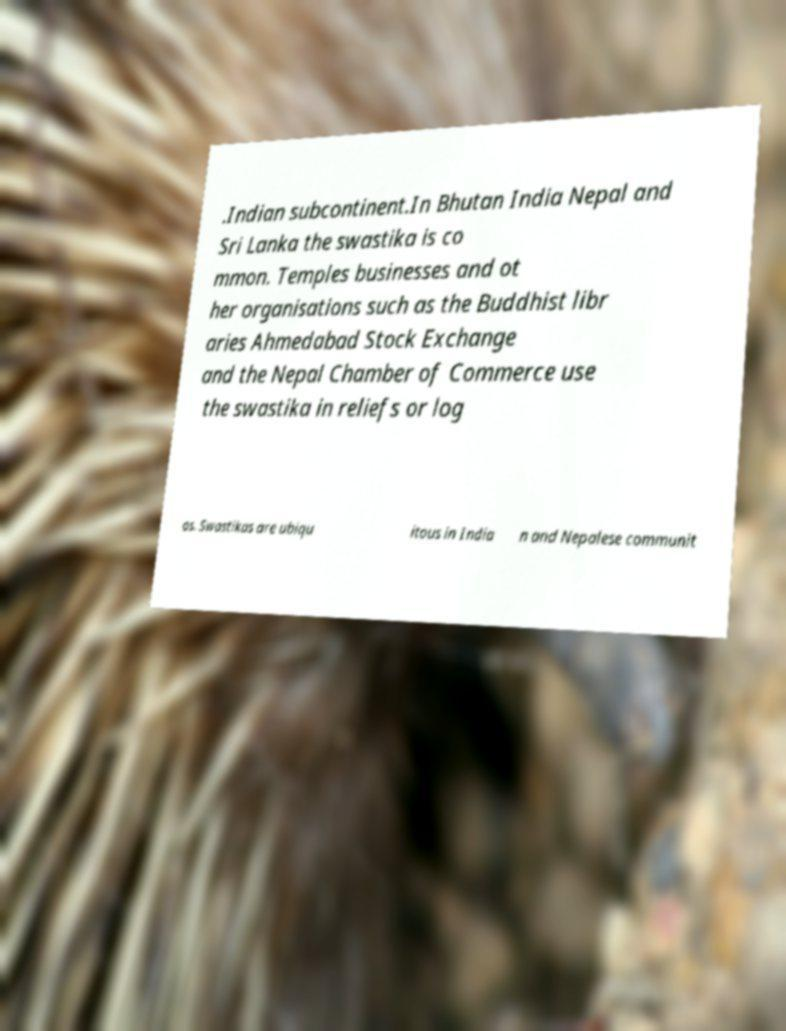There's text embedded in this image that I need extracted. Can you transcribe it verbatim? .Indian subcontinent.In Bhutan India Nepal and Sri Lanka the swastika is co mmon. Temples businesses and ot her organisations such as the Buddhist libr aries Ahmedabad Stock Exchange and the Nepal Chamber of Commerce use the swastika in reliefs or log os. Swastikas are ubiqu itous in India n and Nepalese communit 